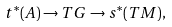<formula> <loc_0><loc_0><loc_500><loc_500>t ^ { * } ( A ) \to T G \to s ^ { * } ( T M ) ,</formula> 